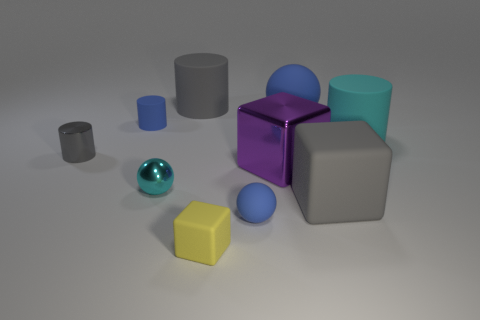Subtract 1 cylinders. How many cylinders are left? 3 Subtract all big blue matte balls. How many balls are left? 2 Subtract all blue cylinders. How many cylinders are left? 3 Subtract all blue cubes. Subtract all red cylinders. How many cubes are left? 3 Subtract all cylinders. How many objects are left? 6 Subtract all cyan cylinders. Subtract all tiny purple matte things. How many objects are left? 9 Add 1 large blue matte objects. How many large blue matte objects are left? 2 Add 1 yellow matte blocks. How many yellow matte blocks exist? 2 Subtract 0 yellow spheres. How many objects are left? 10 